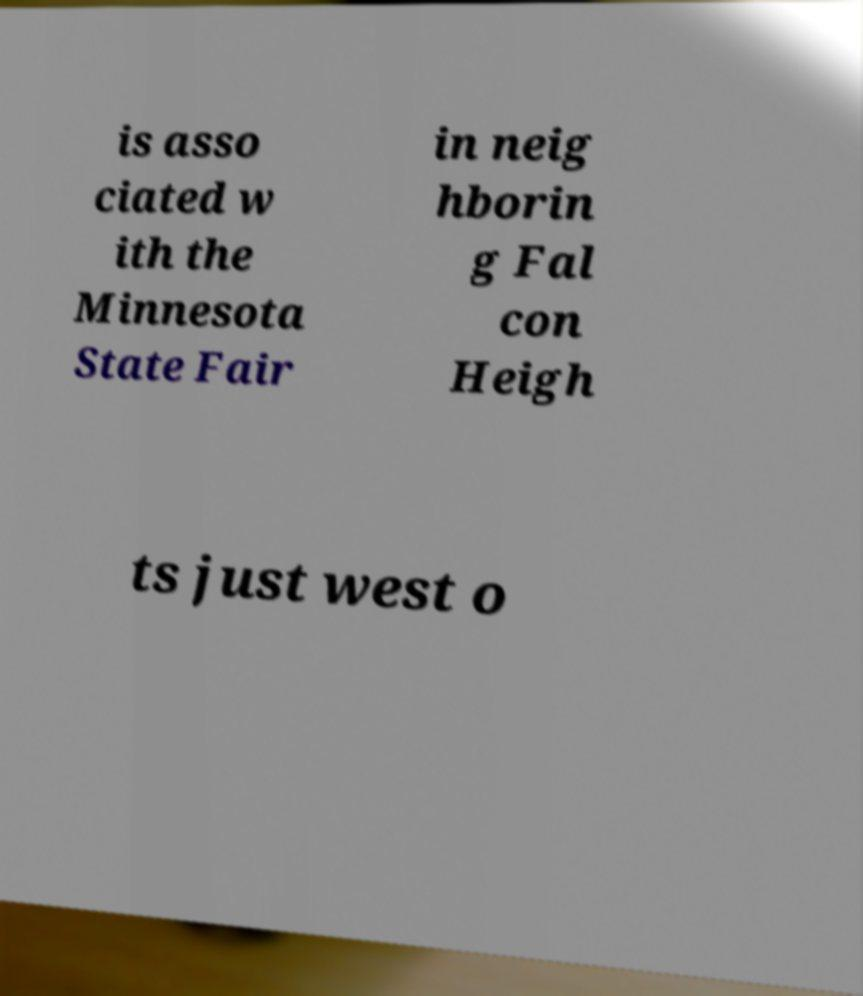There's text embedded in this image that I need extracted. Can you transcribe it verbatim? is asso ciated w ith the Minnesota State Fair in neig hborin g Fal con Heigh ts just west o 